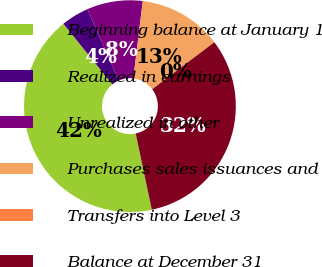Convert chart. <chart><loc_0><loc_0><loc_500><loc_500><pie_chart><fcel>Beginning balance at January 1<fcel>Realized in earnings<fcel>Unrealized in other<fcel>Purchases sales issuances and<fcel>Transfers into Level 3<fcel>Balance at December 31<nl><fcel>42.5%<fcel>4.25%<fcel>8.5%<fcel>12.75%<fcel>0.0%<fcel>32.0%<nl></chart> 